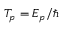Convert formula to latex. <formula><loc_0><loc_0><loc_500><loc_500>T _ { p } = E _ { p } / \hbar</formula> 